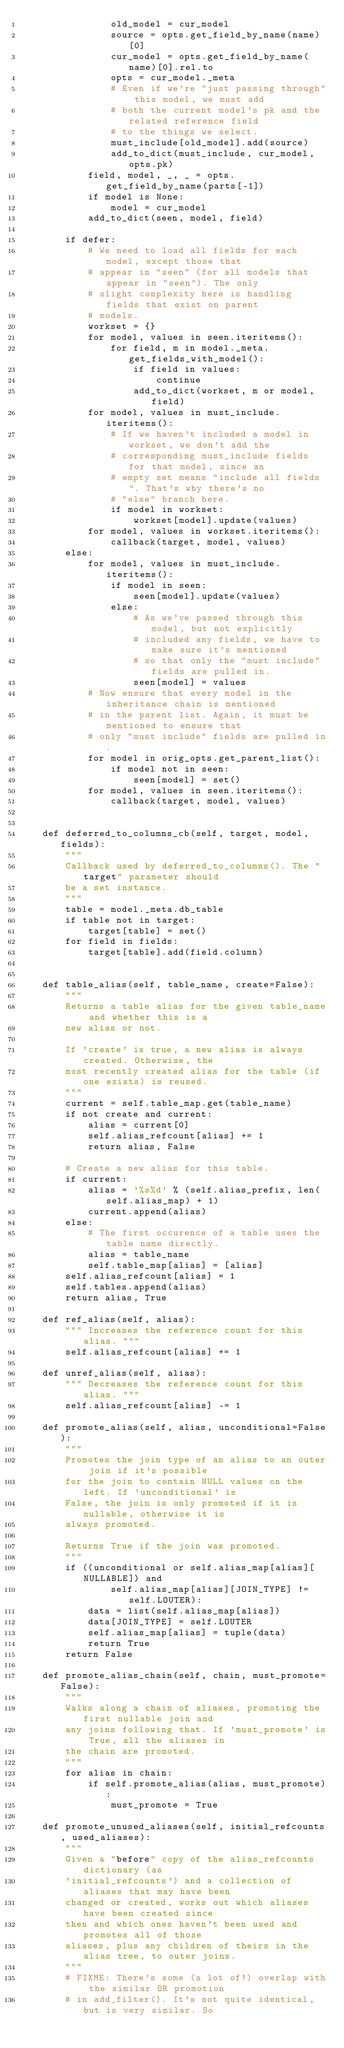<code> <loc_0><loc_0><loc_500><loc_500><_Python_>                old_model = cur_model
                source = opts.get_field_by_name(name)[0]
                cur_model = opts.get_field_by_name(name)[0].rel.to
                opts = cur_model._meta
                # Even if we're "just passing through" this model, we must add
                # both the current model's pk and the related reference field
                # to the things we select.
                must_include[old_model].add(source)
                add_to_dict(must_include, cur_model, opts.pk)
            field, model, _, _ = opts.get_field_by_name(parts[-1])
            if model is None:
                model = cur_model
            add_to_dict(seen, model, field)

        if defer:
            # We need to load all fields for each model, except those that
            # appear in "seen" (for all models that appear in "seen"). The only
            # slight complexity here is handling fields that exist on parent
            # models.
            workset = {}
            for model, values in seen.iteritems():
                for field, m in model._meta.get_fields_with_model():
                    if field in values:
                        continue
                    add_to_dict(workset, m or model, field)
            for model, values in must_include.iteritems():
                # If we haven't included a model in workset, we don't add the
                # corresponding must_include fields for that model, since an
                # empty set means "include all fields". That's why there's no
                # "else" branch here.
                if model in workset:
                    workset[model].update(values)
            for model, values in workset.iteritems():
                callback(target, model, values)
        else:
            for model, values in must_include.iteritems():
                if model in seen:
                    seen[model].update(values)
                else:
                    # As we've passed through this model, but not explicitly
                    # included any fields, we have to make sure it's mentioned
                    # so that only the "must include" fields are pulled in.
                    seen[model] = values
            # Now ensure that every model in the inheritance chain is mentioned
            # in the parent list. Again, it must be mentioned to ensure that
            # only "must include" fields are pulled in.
            for model in orig_opts.get_parent_list():
                if model not in seen:
                    seen[model] = set()
            for model, values in seen.iteritems():
                callback(target, model, values)


    def deferred_to_columns_cb(self, target, model, fields):
        """
        Callback used by deferred_to_columns(). The "target" parameter should
        be a set instance.
        """
        table = model._meta.db_table
        if table not in target:
            target[table] = set()
        for field in fields:
            target[table].add(field.column)


    def table_alias(self, table_name, create=False):
        """
        Returns a table alias for the given table_name and whether this is a
        new alias or not.

        If 'create' is true, a new alias is always created. Otherwise, the
        most recently created alias for the table (if one exists) is reused.
        """
        current = self.table_map.get(table_name)
        if not create and current:
            alias = current[0]
            self.alias_refcount[alias] += 1
            return alias, False

        # Create a new alias for this table.
        if current:
            alias = '%s%d' % (self.alias_prefix, len(self.alias_map) + 1)
            current.append(alias)
        else:
            # The first occurence of a table uses the table name directly.
            alias = table_name
            self.table_map[alias] = [alias]
        self.alias_refcount[alias] = 1
        self.tables.append(alias)
        return alias, True

    def ref_alias(self, alias):
        """ Increases the reference count for this alias. """
        self.alias_refcount[alias] += 1

    def unref_alias(self, alias):
        """ Decreases the reference count for this alias. """
        self.alias_refcount[alias] -= 1

    def promote_alias(self, alias, unconditional=False):
        """
        Promotes the join type of an alias to an outer join if it's possible
        for the join to contain NULL values on the left. If 'unconditional' is
        False, the join is only promoted if it is nullable, otherwise it is
        always promoted.

        Returns True if the join was promoted.
        """
        if ((unconditional or self.alias_map[alias][NULLABLE]) and
                self.alias_map[alias][JOIN_TYPE] != self.LOUTER):
            data = list(self.alias_map[alias])
            data[JOIN_TYPE] = self.LOUTER
            self.alias_map[alias] = tuple(data)
            return True
        return False

    def promote_alias_chain(self, chain, must_promote=False):
        """
        Walks along a chain of aliases, promoting the first nullable join and
        any joins following that. If 'must_promote' is True, all the aliases in
        the chain are promoted.
        """
        for alias in chain:
            if self.promote_alias(alias, must_promote):
                must_promote = True

    def promote_unused_aliases(self, initial_refcounts, used_aliases):
        """
        Given a "before" copy of the alias_refcounts dictionary (as
        'initial_refcounts') and a collection of aliases that may have been
        changed or created, works out which aliases have been created since
        then and which ones haven't been used and promotes all of those
        aliases, plus any children of theirs in the alias tree, to outer joins.
        """
        # FIXME: There's some (a lot of!) overlap with the similar OR promotion
        # in add_filter(). It's not quite identical, but is very similar. So</code> 